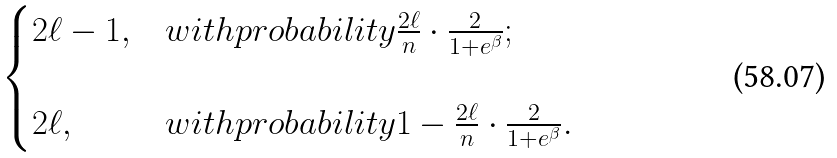<formula> <loc_0><loc_0><loc_500><loc_500>\begin{cases} 2 \ell - 1 , & w i t h p r o b a b i l i t y \frac { 2 \ell } { n } \cdot \frac { 2 } { 1 + e ^ { \beta } } ; \\ \\ 2 \ell , & w i t h p r o b a b i l i t y 1 - \frac { 2 \ell } { n } \cdot \frac { 2 } { 1 + e ^ { \beta } } . \\ \end{cases}</formula> 